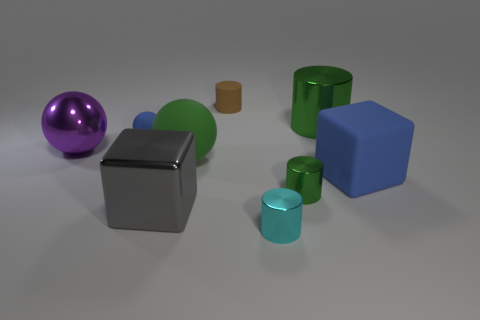Subtract all blue spheres. How many spheres are left? 2 Subtract 1 cylinders. How many cylinders are left? 3 Subtract all purple balls. How many balls are left? 2 Subtract all cylinders. How many objects are left? 5 Add 3 tiny brown rubber cylinders. How many tiny brown rubber cylinders exist? 4 Subtract 0 blue cylinders. How many objects are left? 9 Subtract all yellow spheres. Subtract all gray cubes. How many spheres are left? 3 Subtract all green cylinders. How many gray blocks are left? 1 Subtract all big purple metal cubes. Subtract all large green matte objects. How many objects are left? 8 Add 4 tiny shiny cylinders. How many tiny shiny cylinders are left? 6 